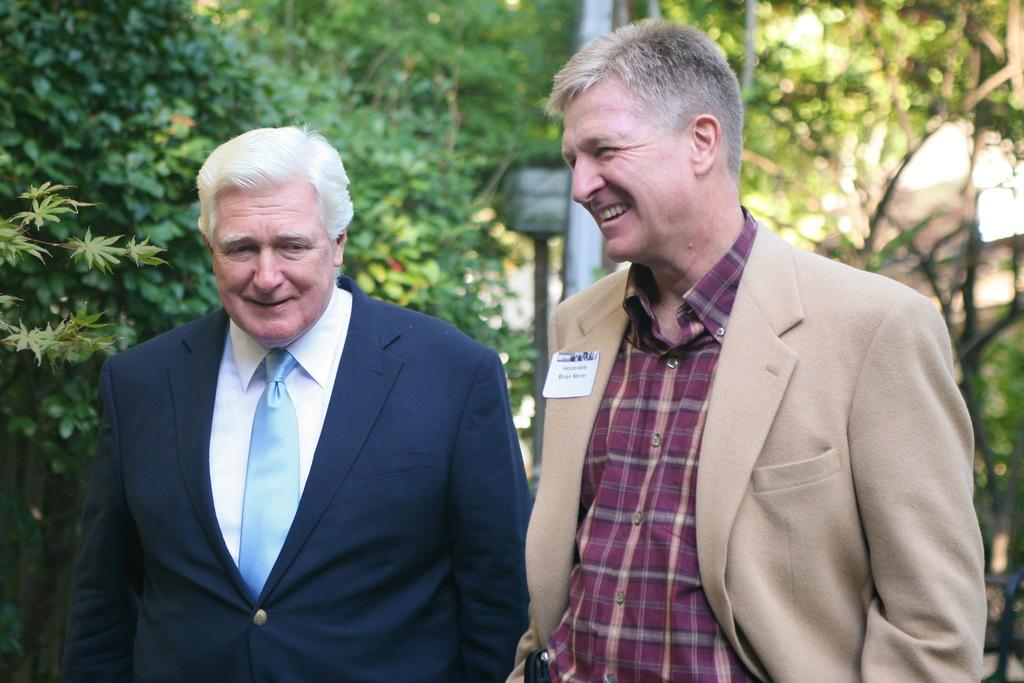How many people are in the image? There are two men standing in the image. What are the men wearing? The men are wearing coats. What can be seen in the background of the image? There are plants and trees in the background of the image. What type of grain is being harvested by the bear in the image? There is no bear present in the image, and therefore no grain harvesting can be observed. What is the quill used for in the image? There is no quill present in the image. 